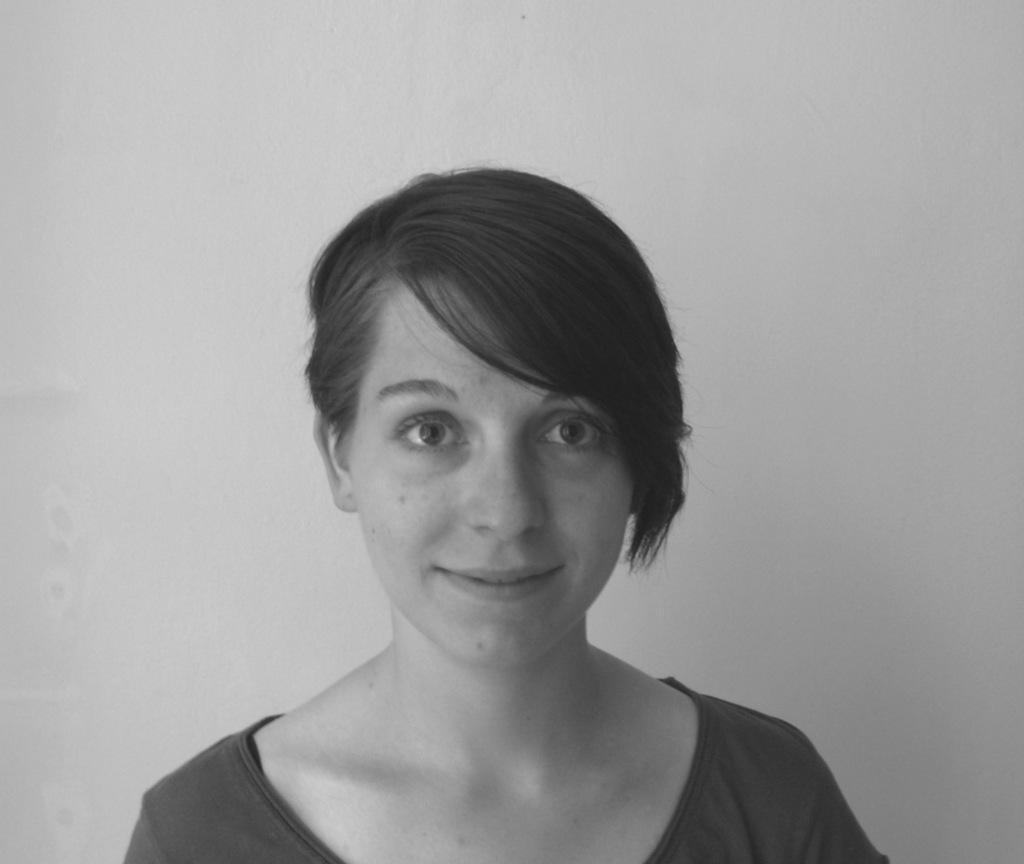Could you give a brief overview of what you see in this image? This is a black and white image. A woman is present. There is a wall at the back. 